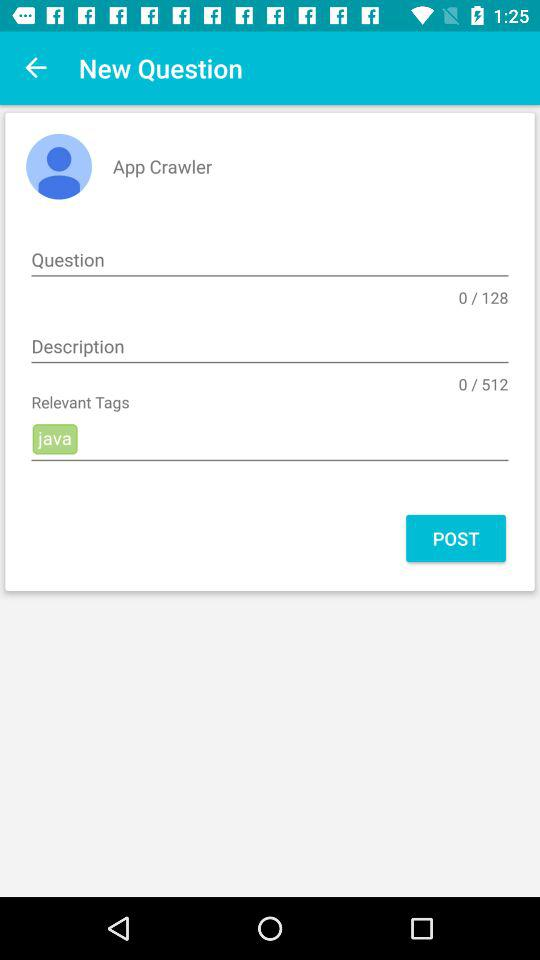What are the relevant tags? The relevant tag is "java". 